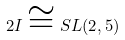<formula> <loc_0><loc_0><loc_500><loc_500>2 I \cong S L ( 2 , 5 )</formula> 